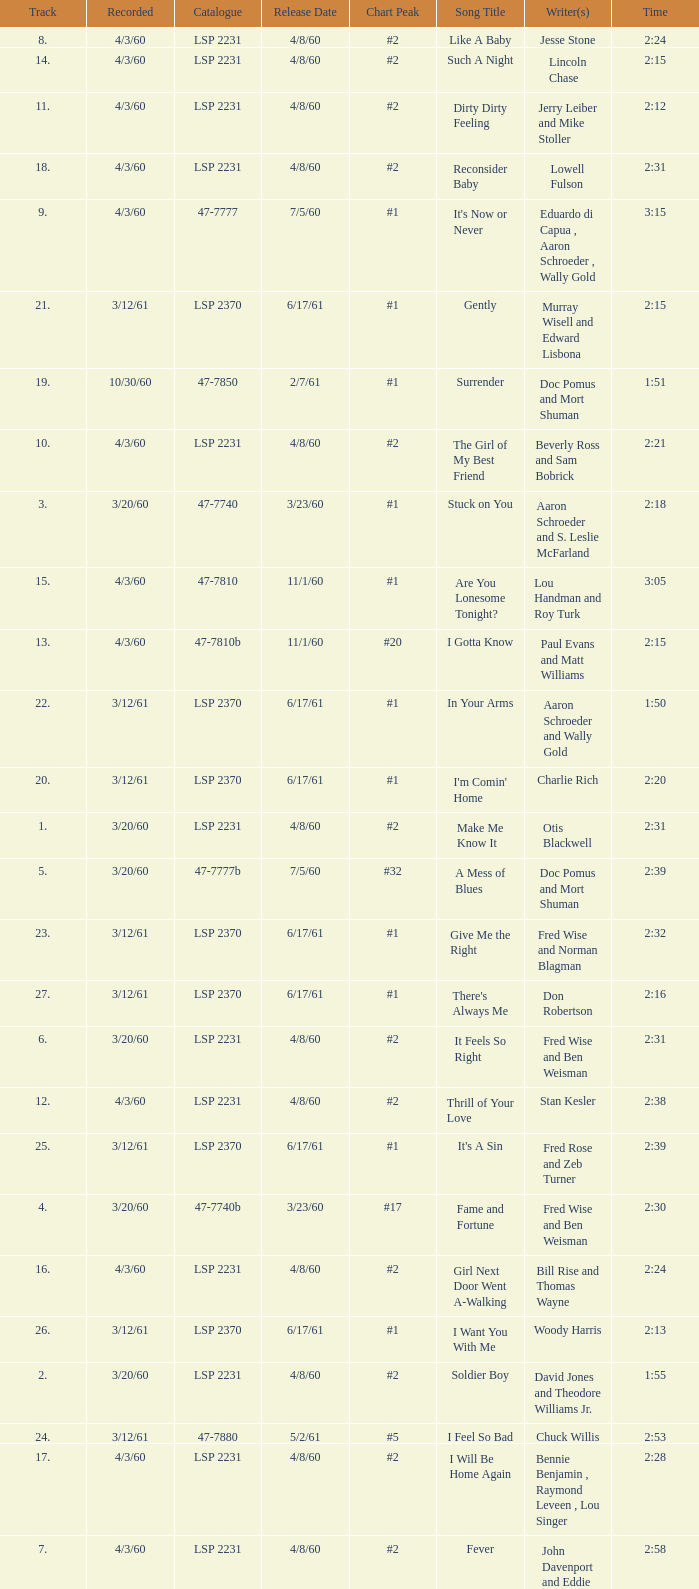On songs with track numbers smaller than number 17 and catalogues of LSP 2231, who are the writer(s)? Otis Blackwell, David Jones and Theodore Williams Jr., Fred Wise and Ben Weisman, John Davenport and Eddie Cooley, Jesse Stone, Beverly Ross and Sam Bobrick, Jerry Leiber and Mike Stoller, Stan Kesler, Lincoln Chase, Bill Rise and Thomas Wayne. 